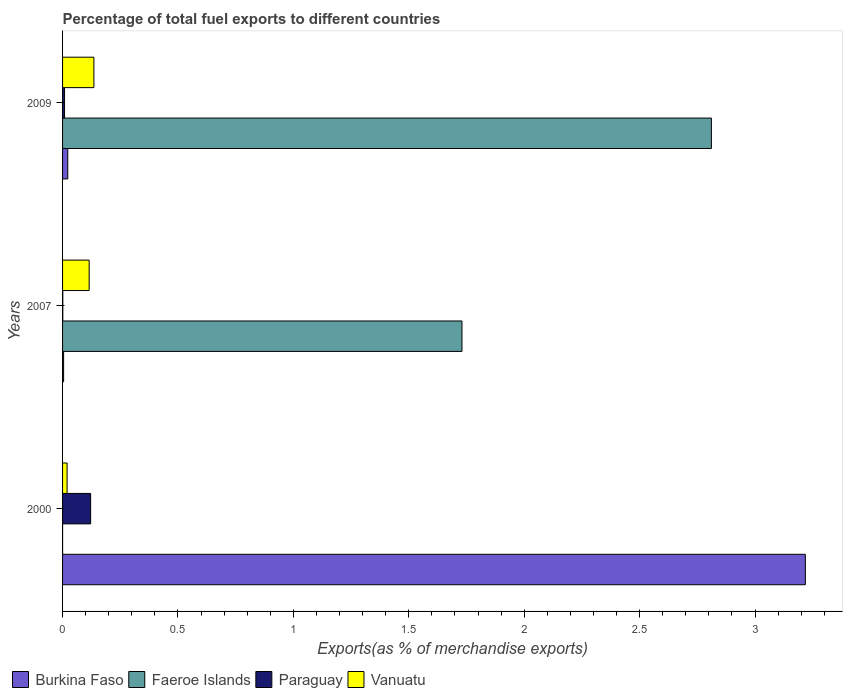Are the number of bars on each tick of the Y-axis equal?
Ensure brevity in your answer.  Yes. How many bars are there on the 2nd tick from the bottom?
Keep it short and to the point. 4. In how many cases, is the number of bars for a given year not equal to the number of legend labels?
Provide a succinct answer. 0. What is the percentage of exports to different countries in Paraguay in 2009?
Offer a terse response. 0.01. Across all years, what is the maximum percentage of exports to different countries in Paraguay?
Provide a succinct answer. 0.12. Across all years, what is the minimum percentage of exports to different countries in Faeroe Islands?
Offer a very short reply. 5.55871303274651e-5. What is the total percentage of exports to different countries in Burkina Faso in the graph?
Give a very brief answer. 3.24. What is the difference between the percentage of exports to different countries in Paraguay in 2007 and that in 2009?
Give a very brief answer. -0.01. What is the difference between the percentage of exports to different countries in Burkina Faso in 2009 and the percentage of exports to different countries in Faeroe Islands in 2007?
Your answer should be very brief. -1.71. What is the average percentage of exports to different countries in Burkina Faso per year?
Give a very brief answer. 1.08. In the year 2009, what is the difference between the percentage of exports to different countries in Paraguay and percentage of exports to different countries in Faeroe Islands?
Make the answer very short. -2.8. What is the ratio of the percentage of exports to different countries in Faeroe Islands in 2000 to that in 2007?
Offer a very short reply. 3.212510993227174e-5. Is the difference between the percentage of exports to different countries in Paraguay in 2000 and 2009 greater than the difference between the percentage of exports to different countries in Faeroe Islands in 2000 and 2009?
Provide a succinct answer. Yes. What is the difference between the highest and the second highest percentage of exports to different countries in Burkina Faso?
Ensure brevity in your answer.  3.2. What is the difference between the highest and the lowest percentage of exports to different countries in Burkina Faso?
Provide a succinct answer. 3.21. Is the sum of the percentage of exports to different countries in Paraguay in 2000 and 2009 greater than the maximum percentage of exports to different countries in Faeroe Islands across all years?
Ensure brevity in your answer.  No. What does the 4th bar from the top in 2009 represents?
Keep it short and to the point. Burkina Faso. What does the 3rd bar from the bottom in 2009 represents?
Your answer should be compact. Paraguay. Is it the case that in every year, the sum of the percentage of exports to different countries in Paraguay and percentage of exports to different countries in Faeroe Islands is greater than the percentage of exports to different countries in Vanuatu?
Offer a very short reply. Yes. How many bars are there?
Make the answer very short. 12. How many years are there in the graph?
Your answer should be very brief. 3. What is the difference between two consecutive major ticks on the X-axis?
Provide a short and direct response. 0.5. Are the values on the major ticks of X-axis written in scientific E-notation?
Provide a succinct answer. No. Does the graph contain any zero values?
Your answer should be compact. No. Does the graph contain grids?
Provide a succinct answer. No. What is the title of the graph?
Keep it short and to the point. Percentage of total fuel exports to different countries. What is the label or title of the X-axis?
Your answer should be very brief. Exports(as % of merchandise exports). What is the label or title of the Y-axis?
Ensure brevity in your answer.  Years. What is the Exports(as % of merchandise exports) in Burkina Faso in 2000?
Offer a terse response. 3.22. What is the Exports(as % of merchandise exports) of Faeroe Islands in 2000?
Offer a terse response. 5.55871303274651e-5. What is the Exports(as % of merchandise exports) of Paraguay in 2000?
Offer a terse response. 0.12. What is the Exports(as % of merchandise exports) in Vanuatu in 2000?
Give a very brief answer. 0.02. What is the Exports(as % of merchandise exports) of Burkina Faso in 2007?
Offer a terse response. 0. What is the Exports(as % of merchandise exports) in Faeroe Islands in 2007?
Provide a short and direct response. 1.73. What is the Exports(as % of merchandise exports) in Paraguay in 2007?
Provide a short and direct response. 0. What is the Exports(as % of merchandise exports) of Vanuatu in 2007?
Keep it short and to the point. 0.12. What is the Exports(as % of merchandise exports) of Burkina Faso in 2009?
Offer a terse response. 0.02. What is the Exports(as % of merchandise exports) of Faeroe Islands in 2009?
Your response must be concise. 2.81. What is the Exports(as % of merchandise exports) of Paraguay in 2009?
Offer a very short reply. 0.01. What is the Exports(as % of merchandise exports) of Vanuatu in 2009?
Your answer should be compact. 0.14. Across all years, what is the maximum Exports(as % of merchandise exports) of Burkina Faso?
Your answer should be very brief. 3.22. Across all years, what is the maximum Exports(as % of merchandise exports) in Faeroe Islands?
Ensure brevity in your answer.  2.81. Across all years, what is the maximum Exports(as % of merchandise exports) of Paraguay?
Provide a succinct answer. 0.12. Across all years, what is the maximum Exports(as % of merchandise exports) of Vanuatu?
Your response must be concise. 0.14. Across all years, what is the minimum Exports(as % of merchandise exports) in Burkina Faso?
Provide a succinct answer. 0. Across all years, what is the minimum Exports(as % of merchandise exports) of Faeroe Islands?
Ensure brevity in your answer.  5.55871303274651e-5. Across all years, what is the minimum Exports(as % of merchandise exports) of Paraguay?
Ensure brevity in your answer.  0. Across all years, what is the minimum Exports(as % of merchandise exports) of Vanuatu?
Ensure brevity in your answer.  0.02. What is the total Exports(as % of merchandise exports) in Burkina Faso in the graph?
Ensure brevity in your answer.  3.24. What is the total Exports(as % of merchandise exports) of Faeroe Islands in the graph?
Provide a succinct answer. 4.54. What is the total Exports(as % of merchandise exports) of Paraguay in the graph?
Make the answer very short. 0.13. What is the total Exports(as % of merchandise exports) of Vanuatu in the graph?
Keep it short and to the point. 0.27. What is the difference between the Exports(as % of merchandise exports) of Burkina Faso in 2000 and that in 2007?
Your answer should be very brief. 3.21. What is the difference between the Exports(as % of merchandise exports) of Faeroe Islands in 2000 and that in 2007?
Offer a very short reply. -1.73. What is the difference between the Exports(as % of merchandise exports) in Paraguay in 2000 and that in 2007?
Your answer should be compact. 0.12. What is the difference between the Exports(as % of merchandise exports) of Vanuatu in 2000 and that in 2007?
Make the answer very short. -0.1. What is the difference between the Exports(as % of merchandise exports) of Burkina Faso in 2000 and that in 2009?
Provide a short and direct response. 3.2. What is the difference between the Exports(as % of merchandise exports) in Faeroe Islands in 2000 and that in 2009?
Your answer should be very brief. -2.81. What is the difference between the Exports(as % of merchandise exports) in Paraguay in 2000 and that in 2009?
Provide a succinct answer. 0.11. What is the difference between the Exports(as % of merchandise exports) in Vanuatu in 2000 and that in 2009?
Keep it short and to the point. -0.12. What is the difference between the Exports(as % of merchandise exports) of Burkina Faso in 2007 and that in 2009?
Offer a very short reply. -0.02. What is the difference between the Exports(as % of merchandise exports) of Faeroe Islands in 2007 and that in 2009?
Provide a succinct answer. -1.08. What is the difference between the Exports(as % of merchandise exports) in Paraguay in 2007 and that in 2009?
Your response must be concise. -0.01. What is the difference between the Exports(as % of merchandise exports) in Vanuatu in 2007 and that in 2009?
Give a very brief answer. -0.02. What is the difference between the Exports(as % of merchandise exports) of Burkina Faso in 2000 and the Exports(as % of merchandise exports) of Faeroe Islands in 2007?
Provide a short and direct response. 1.49. What is the difference between the Exports(as % of merchandise exports) in Burkina Faso in 2000 and the Exports(as % of merchandise exports) in Paraguay in 2007?
Provide a short and direct response. 3.22. What is the difference between the Exports(as % of merchandise exports) in Burkina Faso in 2000 and the Exports(as % of merchandise exports) in Vanuatu in 2007?
Provide a short and direct response. 3.1. What is the difference between the Exports(as % of merchandise exports) of Faeroe Islands in 2000 and the Exports(as % of merchandise exports) of Paraguay in 2007?
Your answer should be compact. -0. What is the difference between the Exports(as % of merchandise exports) in Faeroe Islands in 2000 and the Exports(as % of merchandise exports) in Vanuatu in 2007?
Your response must be concise. -0.12. What is the difference between the Exports(as % of merchandise exports) of Paraguay in 2000 and the Exports(as % of merchandise exports) of Vanuatu in 2007?
Your answer should be compact. 0.01. What is the difference between the Exports(as % of merchandise exports) in Burkina Faso in 2000 and the Exports(as % of merchandise exports) in Faeroe Islands in 2009?
Offer a terse response. 0.41. What is the difference between the Exports(as % of merchandise exports) in Burkina Faso in 2000 and the Exports(as % of merchandise exports) in Paraguay in 2009?
Offer a terse response. 3.21. What is the difference between the Exports(as % of merchandise exports) of Burkina Faso in 2000 and the Exports(as % of merchandise exports) of Vanuatu in 2009?
Provide a succinct answer. 3.08. What is the difference between the Exports(as % of merchandise exports) in Faeroe Islands in 2000 and the Exports(as % of merchandise exports) in Paraguay in 2009?
Keep it short and to the point. -0.01. What is the difference between the Exports(as % of merchandise exports) of Faeroe Islands in 2000 and the Exports(as % of merchandise exports) of Vanuatu in 2009?
Offer a very short reply. -0.14. What is the difference between the Exports(as % of merchandise exports) of Paraguay in 2000 and the Exports(as % of merchandise exports) of Vanuatu in 2009?
Your response must be concise. -0.01. What is the difference between the Exports(as % of merchandise exports) of Burkina Faso in 2007 and the Exports(as % of merchandise exports) of Faeroe Islands in 2009?
Offer a terse response. -2.81. What is the difference between the Exports(as % of merchandise exports) in Burkina Faso in 2007 and the Exports(as % of merchandise exports) in Paraguay in 2009?
Your answer should be very brief. -0. What is the difference between the Exports(as % of merchandise exports) in Burkina Faso in 2007 and the Exports(as % of merchandise exports) in Vanuatu in 2009?
Provide a succinct answer. -0.13. What is the difference between the Exports(as % of merchandise exports) in Faeroe Islands in 2007 and the Exports(as % of merchandise exports) in Paraguay in 2009?
Provide a succinct answer. 1.72. What is the difference between the Exports(as % of merchandise exports) in Faeroe Islands in 2007 and the Exports(as % of merchandise exports) in Vanuatu in 2009?
Provide a succinct answer. 1.59. What is the difference between the Exports(as % of merchandise exports) in Paraguay in 2007 and the Exports(as % of merchandise exports) in Vanuatu in 2009?
Ensure brevity in your answer.  -0.13. What is the average Exports(as % of merchandise exports) of Burkina Faso per year?
Your answer should be compact. 1.08. What is the average Exports(as % of merchandise exports) of Faeroe Islands per year?
Offer a terse response. 1.51. What is the average Exports(as % of merchandise exports) of Paraguay per year?
Ensure brevity in your answer.  0.04. What is the average Exports(as % of merchandise exports) of Vanuatu per year?
Ensure brevity in your answer.  0.09. In the year 2000, what is the difference between the Exports(as % of merchandise exports) of Burkina Faso and Exports(as % of merchandise exports) of Faeroe Islands?
Give a very brief answer. 3.22. In the year 2000, what is the difference between the Exports(as % of merchandise exports) of Burkina Faso and Exports(as % of merchandise exports) of Paraguay?
Your answer should be very brief. 3.1. In the year 2000, what is the difference between the Exports(as % of merchandise exports) of Burkina Faso and Exports(as % of merchandise exports) of Vanuatu?
Ensure brevity in your answer.  3.2. In the year 2000, what is the difference between the Exports(as % of merchandise exports) of Faeroe Islands and Exports(as % of merchandise exports) of Paraguay?
Your response must be concise. -0.12. In the year 2000, what is the difference between the Exports(as % of merchandise exports) in Faeroe Islands and Exports(as % of merchandise exports) in Vanuatu?
Give a very brief answer. -0.02. In the year 2000, what is the difference between the Exports(as % of merchandise exports) of Paraguay and Exports(as % of merchandise exports) of Vanuatu?
Offer a very short reply. 0.1. In the year 2007, what is the difference between the Exports(as % of merchandise exports) of Burkina Faso and Exports(as % of merchandise exports) of Faeroe Islands?
Your answer should be very brief. -1.73. In the year 2007, what is the difference between the Exports(as % of merchandise exports) of Burkina Faso and Exports(as % of merchandise exports) of Paraguay?
Make the answer very short. 0. In the year 2007, what is the difference between the Exports(as % of merchandise exports) of Burkina Faso and Exports(as % of merchandise exports) of Vanuatu?
Offer a terse response. -0.11. In the year 2007, what is the difference between the Exports(as % of merchandise exports) in Faeroe Islands and Exports(as % of merchandise exports) in Paraguay?
Offer a terse response. 1.73. In the year 2007, what is the difference between the Exports(as % of merchandise exports) of Faeroe Islands and Exports(as % of merchandise exports) of Vanuatu?
Keep it short and to the point. 1.62. In the year 2007, what is the difference between the Exports(as % of merchandise exports) in Paraguay and Exports(as % of merchandise exports) in Vanuatu?
Offer a very short reply. -0.11. In the year 2009, what is the difference between the Exports(as % of merchandise exports) in Burkina Faso and Exports(as % of merchandise exports) in Faeroe Islands?
Give a very brief answer. -2.79. In the year 2009, what is the difference between the Exports(as % of merchandise exports) of Burkina Faso and Exports(as % of merchandise exports) of Paraguay?
Your answer should be very brief. 0.01. In the year 2009, what is the difference between the Exports(as % of merchandise exports) of Burkina Faso and Exports(as % of merchandise exports) of Vanuatu?
Your response must be concise. -0.11. In the year 2009, what is the difference between the Exports(as % of merchandise exports) of Faeroe Islands and Exports(as % of merchandise exports) of Paraguay?
Ensure brevity in your answer.  2.8. In the year 2009, what is the difference between the Exports(as % of merchandise exports) of Faeroe Islands and Exports(as % of merchandise exports) of Vanuatu?
Ensure brevity in your answer.  2.68. In the year 2009, what is the difference between the Exports(as % of merchandise exports) of Paraguay and Exports(as % of merchandise exports) of Vanuatu?
Your response must be concise. -0.13. What is the ratio of the Exports(as % of merchandise exports) in Burkina Faso in 2000 to that in 2007?
Ensure brevity in your answer.  712.72. What is the ratio of the Exports(as % of merchandise exports) in Paraguay in 2000 to that in 2007?
Your response must be concise. 124.71. What is the ratio of the Exports(as % of merchandise exports) of Vanuatu in 2000 to that in 2007?
Keep it short and to the point. 0.17. What is the ratio of the Exports(as % of merchandise exports) of Burkina Faso in 2000 to that in 2009?
Offer a terse response. 143.06. What is the ratio of the Exports(as % of merchandise exports) in Faeroe Islands in 2000 to that in 2009?
Ensure brevity in your answer.  0. What is the ratio of the Exports(as % of merchandise exports) in Paraguay in 2000 to that in 2009?
Offer a very short reply. 14.2. What is the ratio of the Exports(as % of merchandise exports) of Vanuatu in 2000 to that in 2009?
Keep it short and to the point. 0.14. What is the ratio of the Exports(as % of merchandise exports) in Burkina Faso in 2007 to that in 2009?
Your answer should be very brief. 0.2. What is the ratio of the Exports(as % of merchandise exports) of Faeroe Islands in 2007 to that in 2009?
Your answer should be compact. 0.62. What is the ratio of the Exports(as % of merchandise exports) in Paraguay in 2007 to that in 2009?
Your answer should be very brief. 0.11. What is the ratio of the Exports(as % of merchandise exports) in Vanuatu in 2007 to that in 2009?
Offer a terse response. 0.85. What is the difference between the highest and the second highest Exports(as % of merchandise exports) of Burkina Faso?
Ensure brevity in your answer.  3.2. What is the difference between the highest and the second highest Exports(as % of merchandise exports) of Faeroe Islands?
Ensure brevity in your answer.  1.08. What is the difference between the highest and the second highest Exports(as % of merchandise exports) in Paraguay?
Offer a very short reply. 0.11. What is the difference between the highest and the second highest Exports(as % of merchandise exports) in Vanuatu?
Give a very brief answer. 0.02. What is the difference between the highest and the lowest Exports(as % of merchandise exports) of Burkina Faso?
Provide a succinct answer. 3.21. What is the difference between the highest and the lowest Exports(as % of merchandise exports) of Faeroe Islands?
Offer a very short reply. 2.81. What is the difference between the highest and the lowest Exports(as % of merchandise exports) in Paraguay?
Provide a succinct answer. 0.12. What is the difference between the highest and the lowest Exports(as % of merchandise exports) in Vanuatu?
Your answer should be very brief. 0.12. 